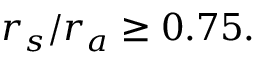<formula> <loc_0><loc_0><loc_500><loc_500>r _ { s } / r _ { a } \geq 0 . 7 5 .</formula> 